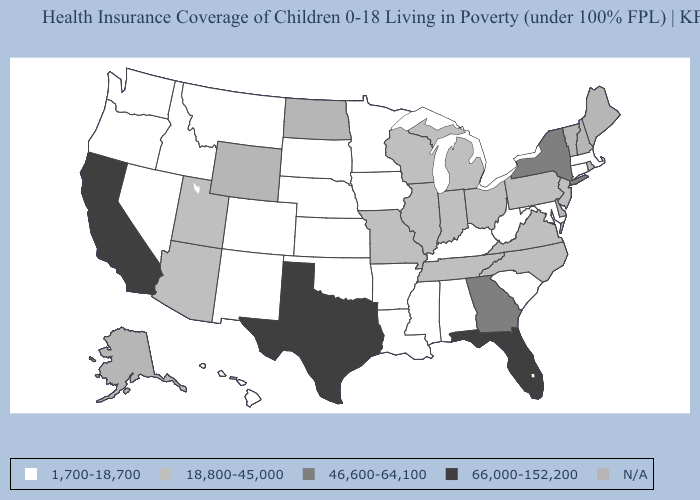Name the states that have a value in the range N/A?
Answer briefly. Alaska, Delaware, Maine, New Hampshire, North Dakota, Rhode Island, Vermont, Wyoming. Among the states that border Illinois , does Wisconsin have the lowest value?
Concise answer only. No. What is the highest value in the USA?
Be succinct. 66,000-152,200. Is the legend a continuous bar?
Short answer required. No. Does Pennsylvania have the highest value in the Northeast?
Write a very short answer. No. Does Texas have the highest value in the South?
Answer briefly. Yes. What is the value of Iowa?
Give a very brief answer. 1,700-18,700. Does New Mexico have the lowest value in the USA?
Keep it brief. Yes. Does Indiana have the highest value in the USA?
Concise answer only. No. Which states hav the highest value in the South?
Keep it brief. Florida, Texas. Does Florida have the highest value in the USA?
Short answer required. Yes. What is the value of South Carolina?
Short answer required. 1,700-18,700. What is the value of Michigan?
Give a very brief answer. 18,800-45,000. 